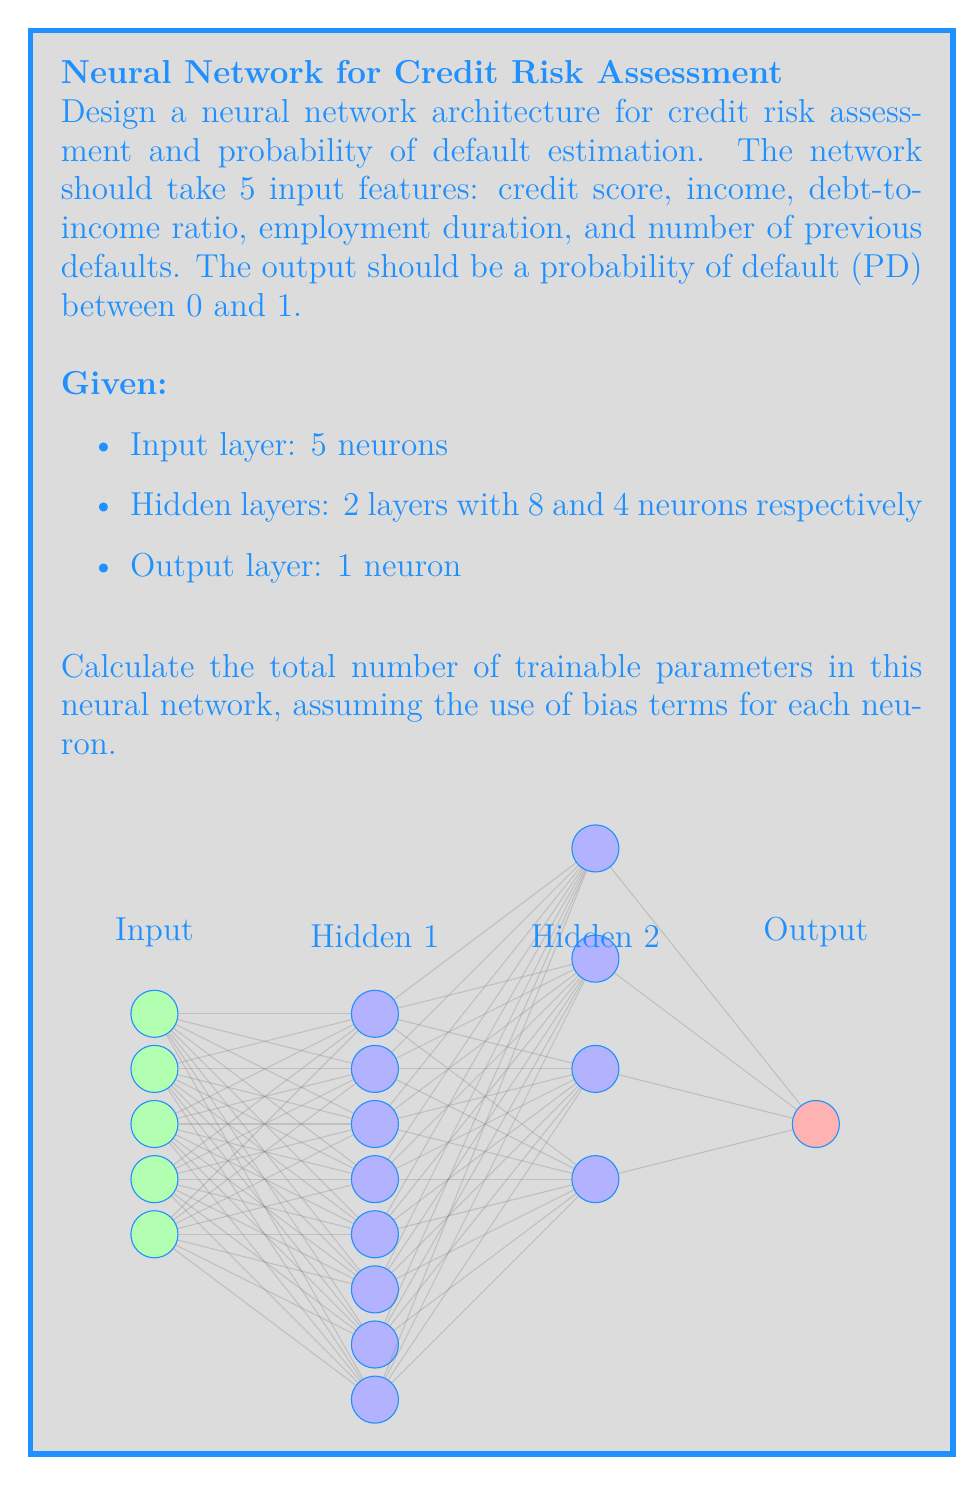Can you answer this question? To calculate the total number of trainable parameters, we need to count the weights and biases for each layer:

1. Input to Hidden 1:
   - Weights: 5 inputs * 8 neurons = 40
   - Biases: 8 (one for each neuron)
   Total: 40 + 8 = 48

2. Hidden 1 to Hidden 2:
   - Weights: 8 inputs * 4 neurons = 32
   - Biases: 4 (one for each neuron)
   Total: 32 + 4 = 36

3. Hidden 2 to Output:
   - Weights: 4 inputs * 1 neuron = 4
   - Biases: 1 (for the output neuron)
   Total: 4 + 1 = 5

The total number of trainable parameters is the sum of all these layers:

$$ \text{Total Parameters} = 48 + 36 + 5 = 89 $$

In Python, you could implement this network using a library like TensorFlow or PyTorch. For example, using TensorFlow:

```python
import tensorflow as tf

model = tf.keras.Sequential([
    tf.keras.layers.Dense(8, activation='relu', input_shape=(5,)),
    tf.keras.layers.Dense(4, activation='relu'),
    tf.keras.layers.Dense(1, activation='sigmoid')
])

model.summary()
```

This would output a summary showing the 89 trainable parameters.
Answer: 89 parameters 